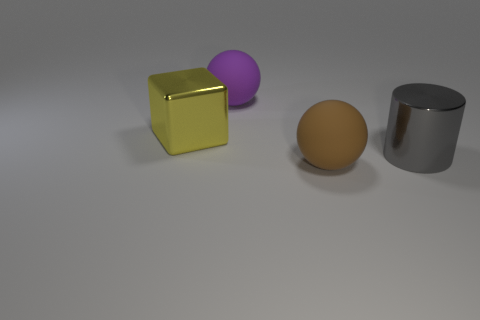Subtract all yellow cylinders. Subtract all red spheres. How many cylinders are left? 1 Add 3 small brown cubes. How many objects exist? 7 Subtract all cubes. How many objects are left? 3 Add 2 spheres. How many spheres are left? 4 Add 1 big red shiny spheres. How many big red shiny spheres exist? 1 Subtract 0 red cubes. How many objects are left? 4 Subtract all large metal spheres. Subtract all large purple objects. How many objects are left? 3 